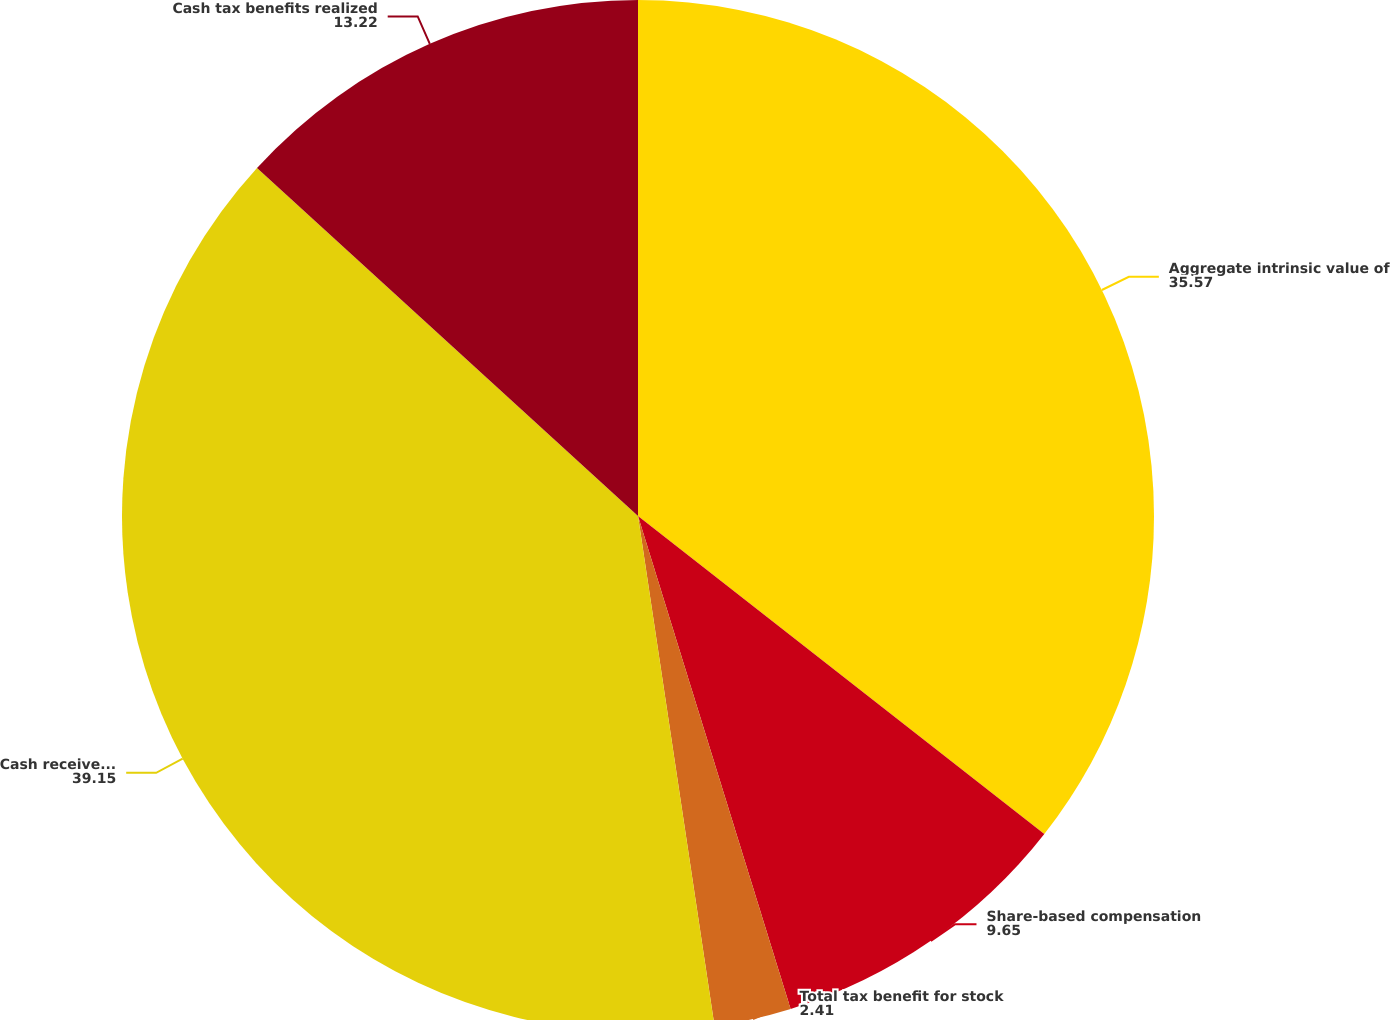Convert chart to OTSL. <chart><loc_0><loc_0><loc_500><loc_500><pie_chart><fcel>Aggregate intrinsic value of<fcel>Share-based compensation<fcel>Total tax benefit for stock<fcel>Cash received from option<fcel>Cash tax benefits realized<nl><fcel>35.57%<fcel>9.65%<fcel>2.41%<fcel>39.15%<fcel>13.22%<nl></chart> 